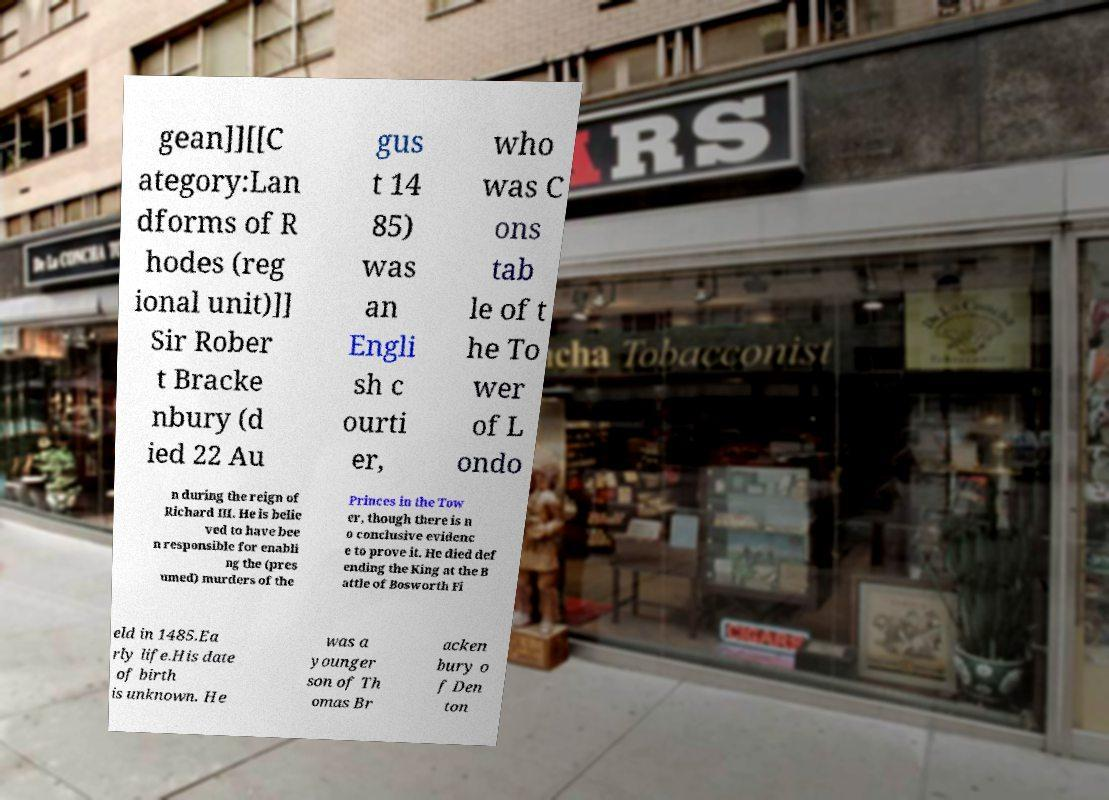Can you accurately transcribe the text from the provided image for me? gean]][[C ategory:Lan dforms of R hodes (reg ional unit)]] Sir Rober t Bracke nbury (d ied 22 Au gus t 14 85) was an Engli sh c ourti er, who was C ons tab le of t he To wer of L ondo n during the reign of Richard III. He is belie ved to have bee n responsible for enabli ng the (pres umed) murders of the Princes in the Tow er, though there is n o conclusive evidenc e to prove it. He died def ending the King at the B attle of Bosworth Fi eld in 1485.Ea rly life.His date of birth is unknown. He was a younger son of Th omas Br acken bury o f Den ton 